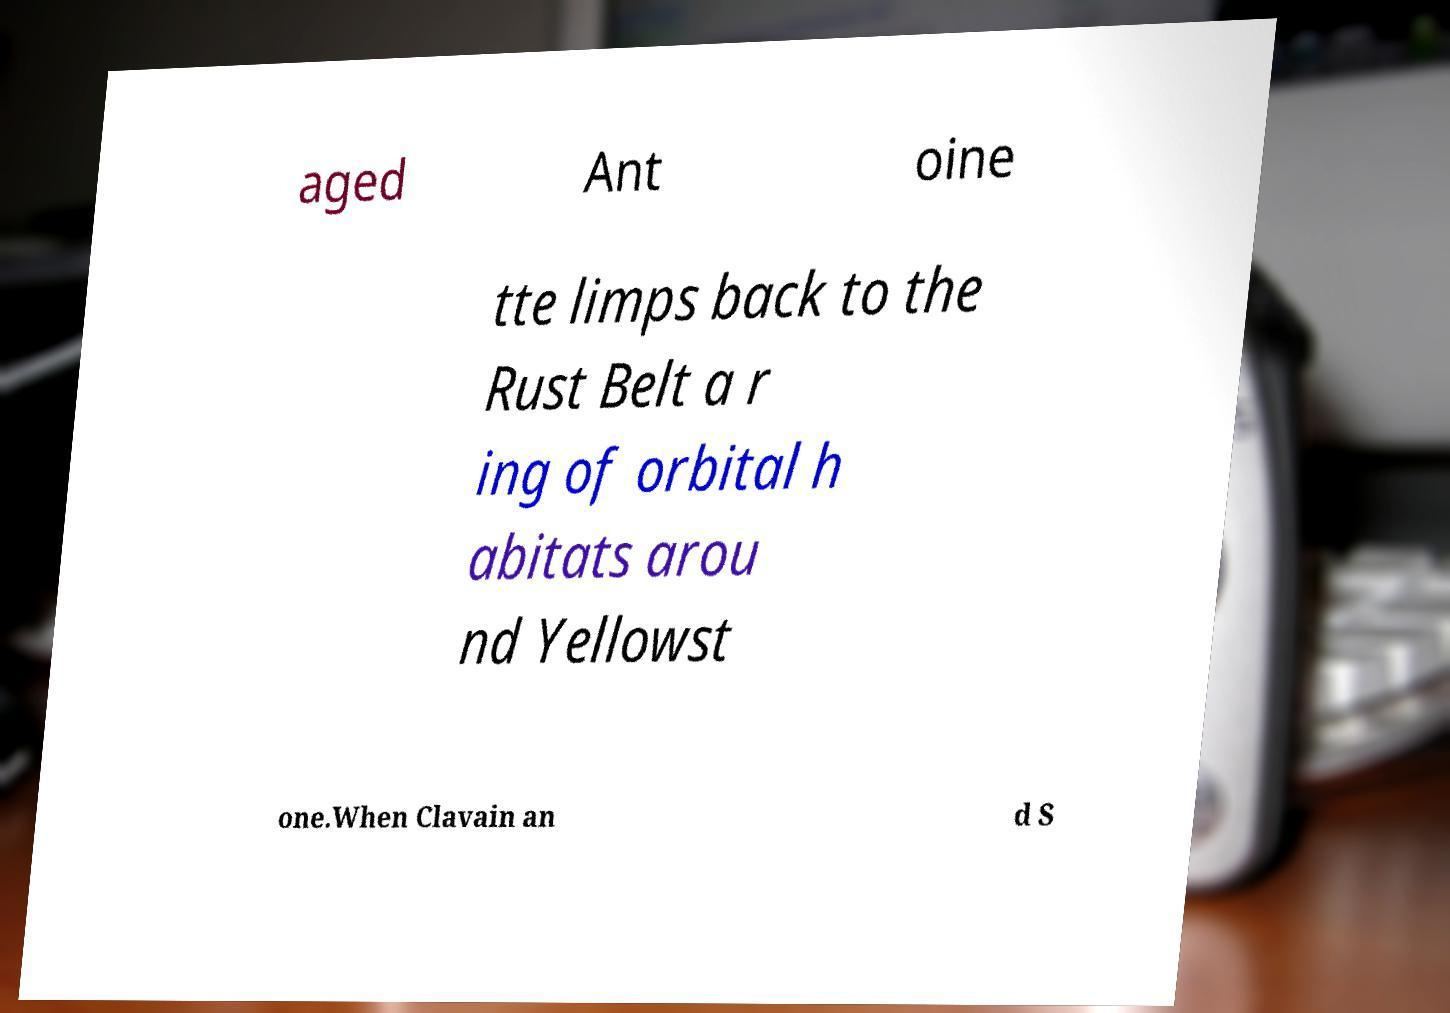Can you accurately transcribe the text from the provided image for me? aged Ant oine tte limps back to the Rust Belt a r ing of orbital h abitats arou nd Yellowst one.When Clavain an d S 